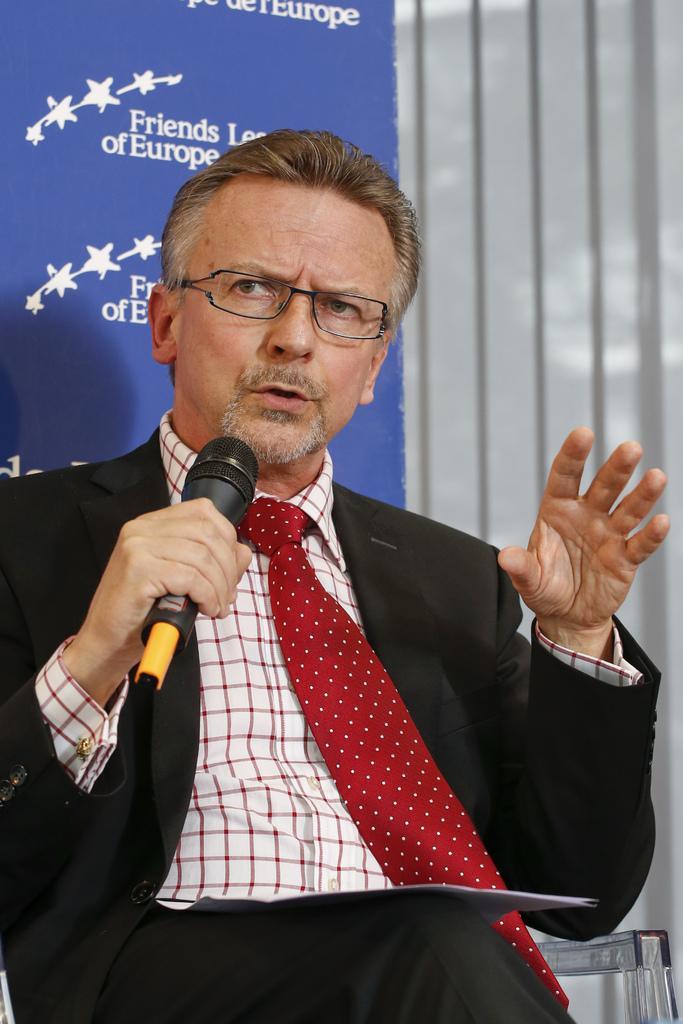Please provide a concise description of this image. In this image we can see a person holding a microphone and behind him we can also see a board with some text. 